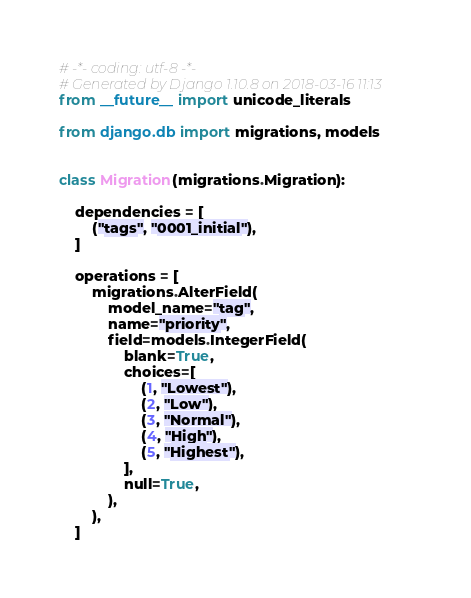<code> <loc_0><loc_0><loc_500><loc_500><_Python_># -*- coding: utf-8 -*-
# Generated by Django 1.10.8 on 2018-03-16 11:13
from __future__ import unicode_literals

from django.db import migrations, models


class Migration(migrations.Migration):

    dependencies = [
        ("tags", "0001_initial"),
    ]

    operations = [
        migrations.AlterField(
            model_name="tag",
            name="priority",
            field=models.IntegerField(
                blank=True,
                choices=[
                    (1, "Lowest"),
                    (2, "Low"),
                    (3, "Normal"),
                    (4, "High"),
                    (5, "Highest"),
                ],
                null=True,
            ),
        ),
    ]
</code> 